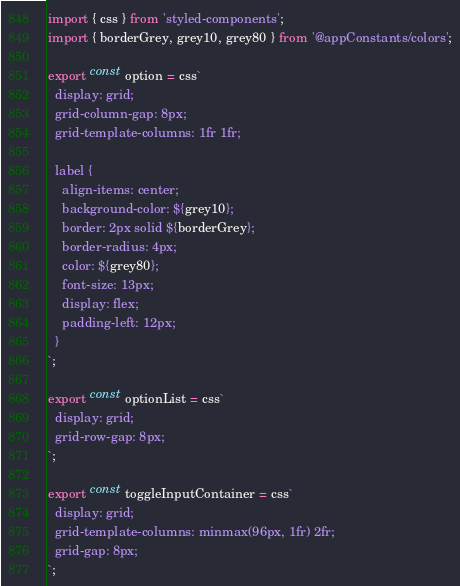Convert code to text. <code><loc_0><loc_0><loc_500><loc_500><_TypeScript_>import { css } from 'styled-components';
import { borderGrey, grey10, grey80 } from '@appConstants/colors';

export const option = css`
  display: grid;
  grid-column-gap: 8px;
  grid-template-columns: 1fr 1fr;

  label {
    align-items: center;
    background-color: ${grey10};
    border: 2px solid ${borderGrey};
    border-radius: 4px;
    color: ${grey80};
    font-size: 13px;
    display: flex;
    padding-left: 12px;
  }
`;

export const optionList = css`
  display: grid;
  grid-row-gap: 8px;
`;

export const toggleInputContainer = css`
  display: grid;
  grid-template-columns: minmax(96px, 1fr) 2fr;
  grid-gap: 8px;
`;
</code> 